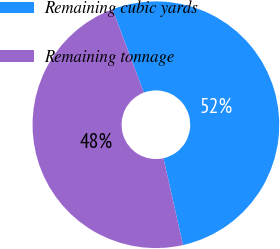<chart> <loc_0><loc_0><loc_500><loc_500><pie_chart><fcel>Remaining cubic yards<fcel>Remaining tonnage<nl><fcel>52.19%<fcel>47.81%<nl></chart> 